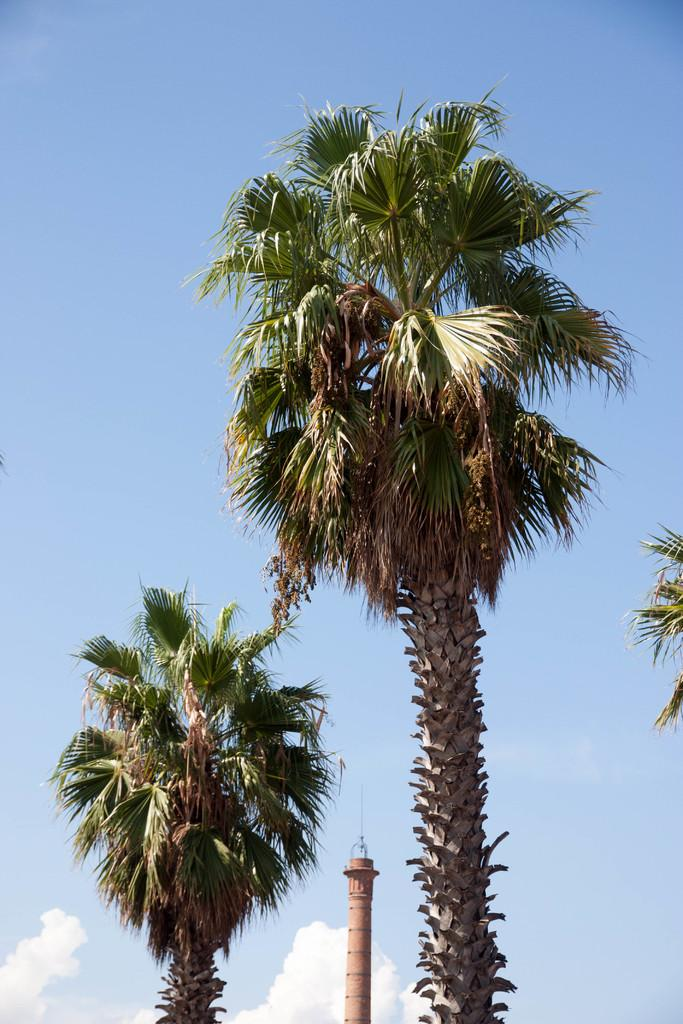What is located in the front of the image? There are trees and a tower in the front of the image. What can be seen in the background of the image? The background of the image includes a blue sky and clouds. How many trees are visible in the front of the image? The number of trees cannot be determined from the image. What type of stocking is hanging from the tower in the image? There is no stocking hanging from the tower in the image. How does the industry depicted in the image contribute to the local economy? There is no industry depicted in the image, so it cannot be determined how it contributes to the local economy. 